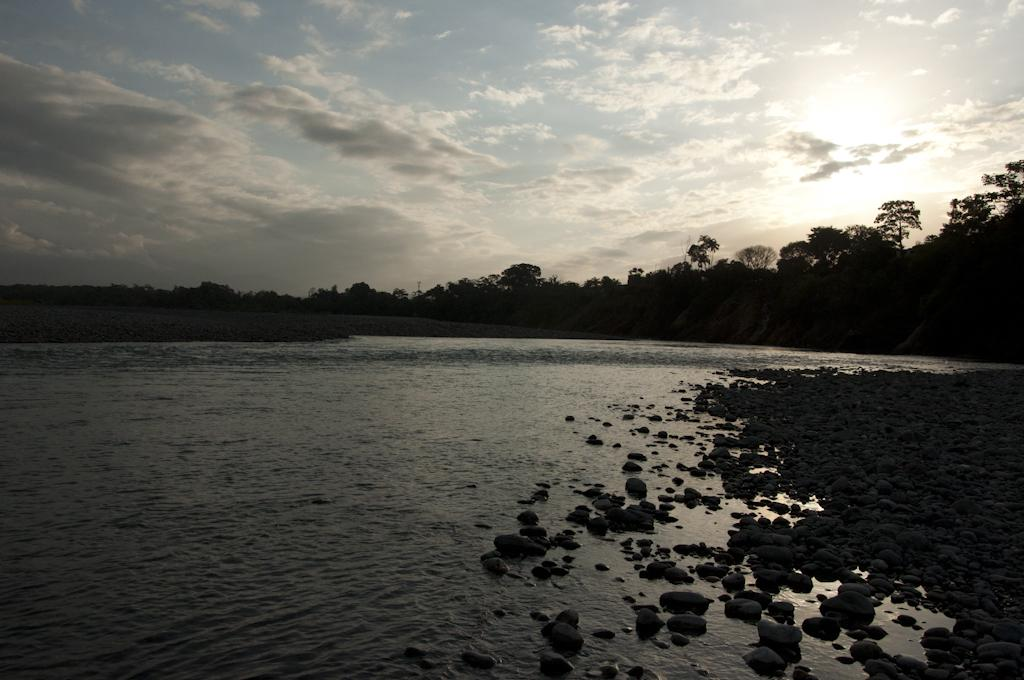What is the main feature of the image? There is a large water body in the image. What else can be seen in the image besides the water body? There are stones visible in the image. Are there any plants or vegetation in the image? Yes, there is a group of trees on the backside of the image. What is visible in the background of the image? The sky is visible in the image. How would you describe the sky in the image? The sky appears cloudy. How many women are cooking in the image? There are no women or cooking activities present in the image. 